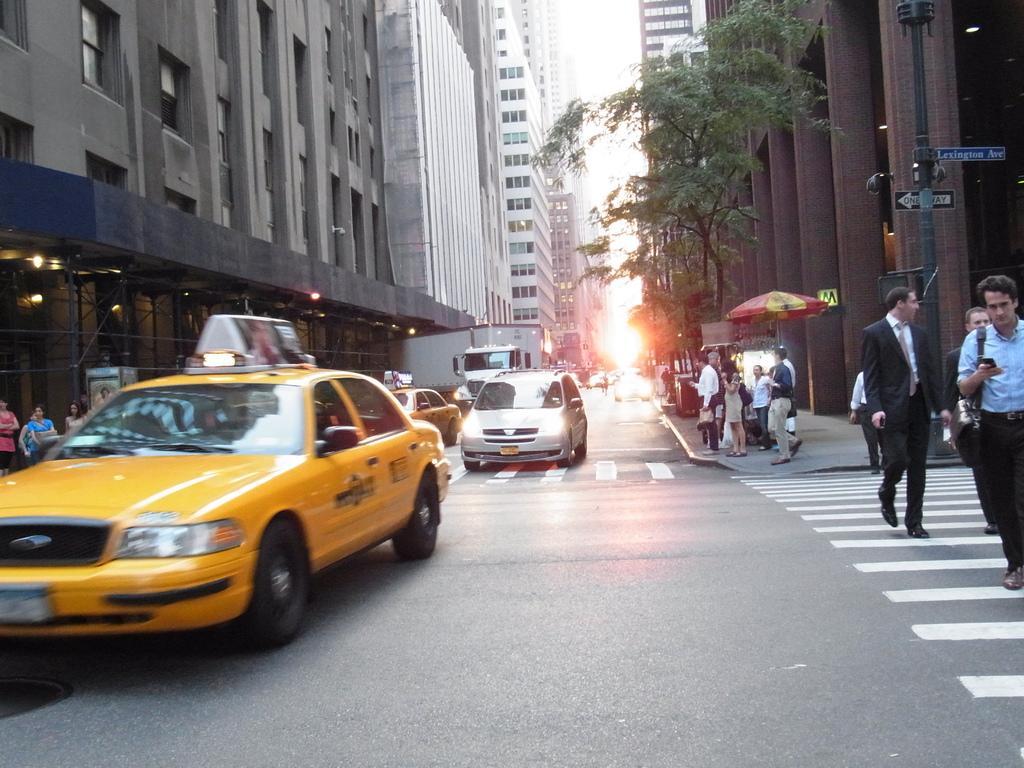Describe this image in one or two sentences. In this picture we can see vehicles on the road and a group of people were some are walking and some are standing on a footpath, umbrella, trees, buildings with windows, lights, name boards attached to a pole and in the background we can see the sky. 